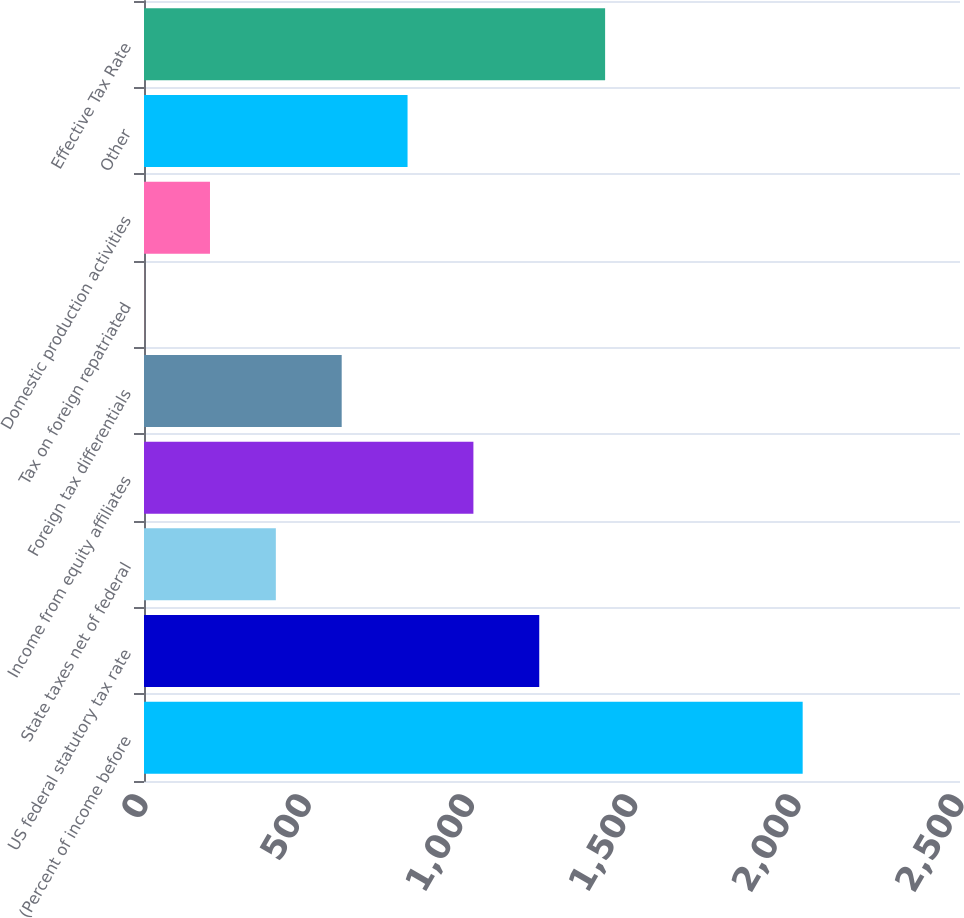Convert chart. <chart><loc_0><loc_0><loc_500><loc_500><bar_chart><fcel>(Percent of income before<fcel>US federal statutory tax rate<fcel>State taxes net of federal<fcel>Income from equity affiliates<fcel>Foreign tax differentials<fcel>Tax on foreign repatriated<fcel>Domestic production activities<fcel>Other<fcel>Effective Tax Rate<nl><fcel>2018<fcel>1210.96<fcel>403.92<fcel>1009.2<fcel>605.68<fcel>0.4<fcel>202.16<fcel>807.44<fcel>1412.72<nl></chart> 